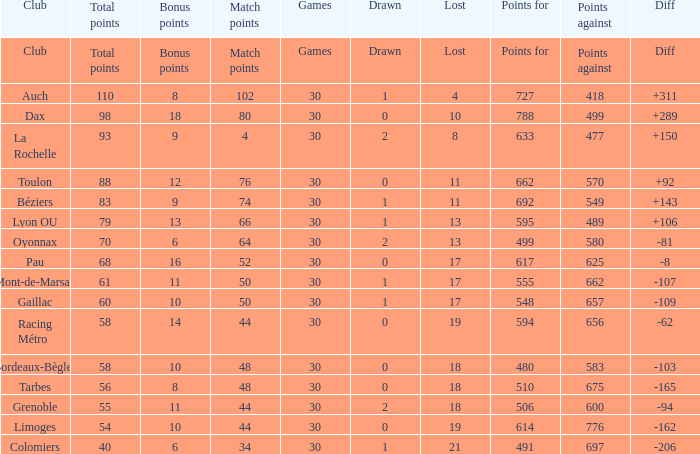What is the number of games for a club that has 34 match points? 30.0. 